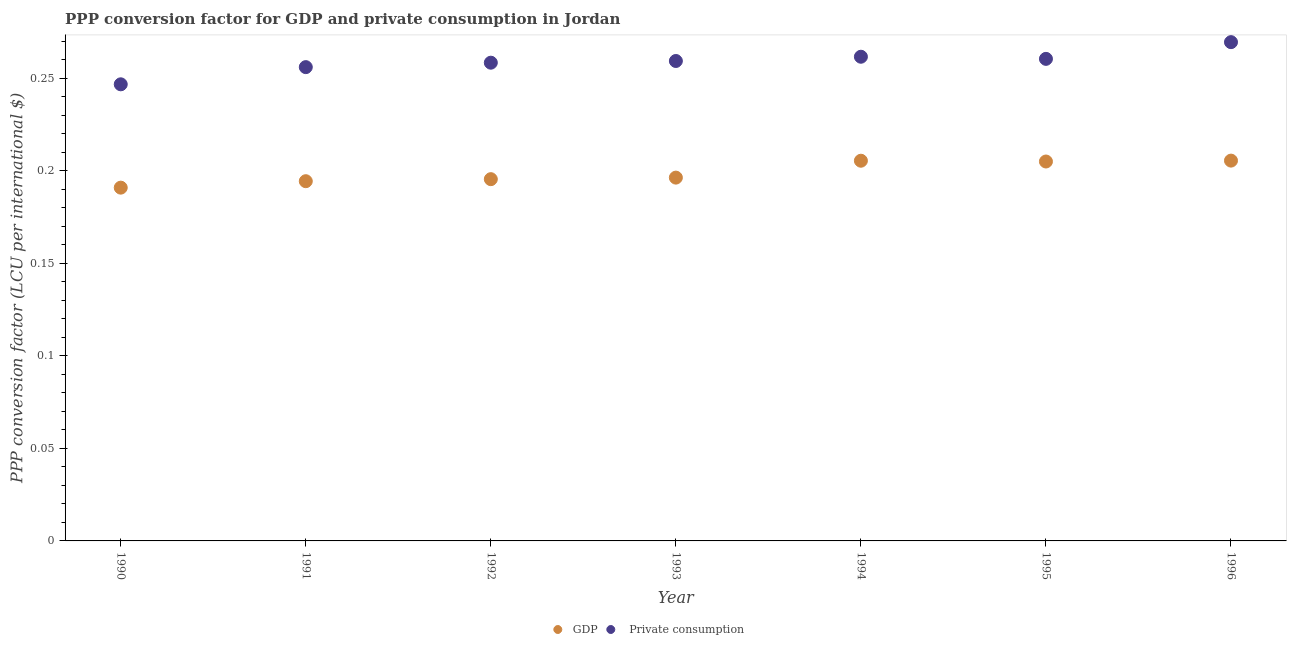How many different coloured dotlines are there?
Make the answer very short. 2. Is the number of dotlines equal to the number of legend labels?
Your response must be concise. Yes. What is the ppp conversion factor for gdp in 1992?
Provide a short and direct response. 0.2. Across all years, what is the maximum ppp conversion factor for private consumption?
Give a very brief answer. 0.27. Across all years, what is the minimum ppp conversion factor for gdp?
Make the answer very short. 0.19. In which year was the ppp conversion factor for private consumption maximum?
Give a very brief answer. 1996. In which year was the ppp conversion factor for gdp minimum?
Give a very brief answer. 1990. What is the total ppp conversion factor for gdp in the graph?
Your response must be concise. 1.39. What is the difference between the ppp conversion factor for private consumption in 1992 and that in 1995?
Make the answer very short. -0. What is the difference between the ppp conversion factor for gdp in 1993 and the ppp conversion factor for private consumption in 1996?
Make the answer very short. -0.07. What is the average ppp conversion factor for private consumption per year?
Your answer should be very brief. 0.26. In the year 1992, what is the difference between the ppp conversion factor for private consumption and ppp conversion factor for gdp?
Give a very brief answer. 0.06. What is the ratio of the ppp conversion factor for gdp in 1990 to that in 1992?
Ensure brevity in your answer.  0.98. Is the ppp conversion factor for private consumption in 1992 less than that in 1995?
Ensure brevity in your answer.  Yes. What is the difference between the highest and the second highest ppp conversion factor for gdp?
Provide a succinct answer. 6.120012639210248e-5. What is the difference between the highest and the lowest ppp conversion factor for gdp?
Your answer should be compact. 0.01. Is the sum of the ppp conversion factor for private consumption in 1994 and 1995 greater than the maximum ppp conversion factor for gdp across all years?
Your response must be concise. Yes. How many years are there in the graph?
Offer a terse response. 7. What is the difference between two consecutive major ticks on the Y-axis?
Offer a terse response. 0.05. Does the graph contain any zero values?
Your response must be concise. No. Where does the legend appear in the graph?
Keep it short and to the point. Bottom center. How many legend labels are there?
Give a very brief answer. 2. How are the legend labels stacked?
Make the answer very short. Horizontal. What is the title of the graph?
Offer a terse response. PPP conversion factor for GDP and private consumption in Jordan. Does "Borrowers" appear as one of the legend labels in the graph?
Give a very brief answer. No. What is the label or title of the X-axis?
Offer a very short reply. Year. What is the label or title of the Y-axis?
Provide a succinct answer. PPP conversion factor (LCU per international $). What is the PPP conversion factor (LCU per international $) in GDP in 1990?
Offer a terse response. 0.19. What is the PPP conversion factor (LCU per international $) in  Private consumption in 1990?
Your response must be concise. 0.25. What is the PPP conversion factor (LCU per international $) in GDP in 1991?
Offer a very short reply. 0.19. What is the PPP conversion factor (LCU per international $) in  Private consumption in 1991?
Make the answer very short. 0.26. What is the PPP conversion factor (LCU per international $) of GDP in 1992?
Your response must be concise. 0.2. What is the PPP conversion factor (LCU per international $) in  Private consumption in 1992?
Offer a very short reply. 0.26. What is the PPP conversion factor (LCU per international $) in GDP in 1993?
Provide a short and direct response. 0.2. What is the PPP conversion factor (LCU per international $) of  Private consumption in 1993?
Your answer should be very brief. 0.26. What is the PPP conversion factor (LCU per international $) in GDP in 1994?
Offer a terse response. 0.21. What is the PPP conversion factor (LCU per international $) of  Private consumption in 1994?
Give a very brief answer. 0.26. What is the PPP conversion factor (LCU per international $) in GDP in 1995?
Provide a succinct answer. 0.21. What is the PPP conversion factor (LCU per international $) in  Private consumption in 1995?
Your answer should be very brief. 0.26. What is the PPP conversion factor (LCU per international $) in GDP in 1996?
Provide a short and direct response. 0.21. What is the PPP conversion factor (LCU per international $) of  Private consumption in 1996?
Ensure brevity in your answer.  0.27. Across all years, what is the maximum PPP conversion factor (LCU per international $) of GDP?
Your answer should be very brief. 0.21. Across all years, what is the maximum PPP conversion factor (LCU per international $) in  Private consumption?
Offer a terse response. 0.27. Across all years, what is the minimum PPP conversion factor (LCU per international $) of GDP?
Offer a terse response. 0.19. Across all years, what is the minimum PPP conversion factor (LCU per international $) in  Private consumption?
Ensure brevity in your answer.  0.25. What is the total PPP conversion factor (LCU per international $) of GDP in the graph?
Provide a short and direct response. 1.39. What is the total PPP conversion factor (LCU per international $) of  Private consumption in the graph?
Provide a short and direct response. 1.81. What is the difference between the PPP conversion factor (LCU per international $) of GDP in 1990 and that in 1991?
Your response must be concise. -0. What is the difference between the PPP conversion factor (LCU per international $) of  Private consumption in 1990 and that in 1991?
Give a very brief answer. -0.01. What is the difference between the PPP conversion factor (LCU per international $) of GDP in 1990 and that in 1992?
Make the answer very short. -0. What is the difference between the PPP conversion factor (LCU per international $) in  Private consumption in 1990 and that in 1992?
Your answer should be compact. -0.01. What is the difference between the PPP conversion factor (LCU per international $) in GDP in 1990 and that in 1993?
Your answer should be very brief. -0.01. What is the difference between the PPP conversion factor (LCU per international $) of  Private consumption in 1990 and that in 1993?
Give a very brief answer. -0.01. What is the difference between the PPP conversion factor (LCU per international $) in GDP in 1990 and that in 1994?
Your response must be concise. -0.01. What is the difference between the PPP conversion factor (LCU per international $) of  Private consumption in 1990 and that in 1994?
Keep it short and to the point. -0.01. What is the difference between the PPP conversion factor (LCU per international $) in GDP in 1990 and that in 1995?
Offer a terse response. -0.01. What is the difference between the PPP conversion factor (LCU per international $) in  Private consumption in 1990 and that in 1995?
Provide a short and direct response. -0.01. What is the difference between the PPP conversion factor (LCU per international $) of GDP in 1990 and that in 1996?
Give a very brief answer. -0.01. What is the difference between the PPP conversion factor (LCU per international $) in  Private consumption in 1990 and that in 1996?
Your answer should be very brief. -0.02. What is the difference between the PPP conversion factor (LCU per international $) of GDP in 1991 and that in 1992?
Offer a very short reply. -0. What is the difference between the PPP conversion factor (LCU per international $) in  Private consumption in 1991 and that in 1992?
Keep it short and to the point. -0. What is the difference between the PPP conversion factor (LCU per international $) in GDP in 1991 and that in 1993?
Your answer should be compact. -0. What is the difference between the PPP conversion factor (LCU per international $) of  Private consumption in 1991 and that in 1993?
Offer a very short reply. -0. What is the difference between the PPP conversion factor (LCU per international $) in GDP in 1991 and that in 1994?
Keep it short and to the point. -0.01. What is the difference between the PPP conversion factor (LCU per international $) of  Private consumption in 1991 and that in 1994?
Your answer should be compact. -0.01. What is the difference between the PPP conversion factor (LCU per international $) of GDP in 1991 and that in 1995?
Your response must be concise. -0.01. What is the difference between the PPP conversion factor (LCU per international $) in  Private consumption in 1991 and that in 1995?
Provide a succinct answer. -0. What is the difference between the PPP conversion factor (LCU per international $) of GDP in 1991 and that in 1996?
Give a very brief answer. -0.01. What is the difference between the PPP conversion factor (LCU per international $) in  Private consumption in 1991 and that in 1996?
Offer a very short reply. -0.01. What is the difference between the PPP conversion factor (LCU per international $) in GDP in 1992 and that in 1993?
Give a very brief answer. -0. What is the difference between the PPP conversion factor (LCU per international $) of  Private consumption in 1992 and that in 1993?
Provide a succinct answer. -0. What is the difference between the PPP conversion factor (LCU per international $) of GDP in 1992 and that in 1994?
Keep it short and to the point. -0.01. What is the difference between the PPP conversion factor (LCU per international $) in  Private consumption in 1992 and that in 1994?
Provide a short and direct response. -0. What is the difference between the PPP conversion factor (LCU per international $) of GDP in 1992 and that in 1995?
Your answer should be compact. -0.01. What is the difference between the PPP conversion factor (LCU per international $) in  Private consumption in 1992 and that in 1995?
Your answer should be compact. -0. What is the difference between the PPP conversion factor (LCU per international $) in GDP in 1992 and that in 1996?
Offer a very short reply. -0.01. What is the difference between the PPP conversion factor (LCU per international $) of  Private consumption in 1992 and that in 1996?
Provide a succinct answer. -0.01. What is the difference between the PPP conversion factor (LCU per international $) of GDP in 1993 and that in 1994?
Ensure brevity in your answer.  -0.01. What is the difference between the PPP conversion factor (LCU per international $) in  Private consumption in 1993 and that in 1994?
Offer a very short reply. -0. What is the difference between the PPP conversion factor (LCU per international $) of GDP in 1993 and that in 1995?
Make the answer very short. -0.01. What is the difference between the PPP conversion factor (LCU per international $) of  Private consumption in 1993 and that in 1995?
Offer a very short reply. -0. What is the difference between the PPP conversion factor (LCU per international $) of GDP in 1993 and that in 1996?
Your response must be concise. -0.01. What is the difference between the PPP conversion factor (LCU per international $) of  Private consumption in 1993 and that in 1996?
Offer a very short reply. -0.01. What is the difference between the PPP conversion factor (LCU per international $) in GDP in 1994 and that in 1995?
Make the answer very short. 0. What is the difference between the PPP conversion factor (LCU per international $) in  Private consumption in 1994 and that in 1995?
Provide a short and direct response. 0. What is the difference between the PPP conversion factor (LCU per international $) of GDP in 1994 and that in 1996?
Your answer should be compact. -0. What is the difference between the PPP conversion factor (LCU per international $) of  Private consumption in 1994 and that in 1996?
Give a very brief answer. -0.01. What is the difference between the PPP conversion factor (LCU per international $) of GDP in 1995 and that in 1996?
Provide a succinct answer. -0. What is the difference between the PPP conversion factor (LCU per international $) of  Private consumption in 1995 and that in 1996?
Keep it short and to the point. -0.01. What is the difference between the PPP conversion factor (LCU per international $) in GDP in 1990 and the PPP conversion factor (LCU per international $) in  Private consumption in 1991?
Offer a terse response. -0.07. What is the difference between the PPP conversion factor (LCU per international $) of GDP in 1990 and the PPP conversion factor (LCU per international $) of  Private consumption in 1992?
Your answer should be very brief. -0.07. What is the difference between the PPP conversion factor (LCU per international $) in GDP in 1990 and the PPP conversion factor (LCU per international $) in  Private consumption in 1993?
Provide a short and direct response. -0.07. What is the difference between the PPP conversion factor (LCU per international $) of GDP in 1990 and the PPP conversion factor (LCU per international $) of  Private consumption in 1994?
Offer a terse response. -0.07. What is the difference between the PPP conversion factor (LCU per international $) in GDP in 1990 and the PPP conversion factor (LCU per international $) in  Private consumption in 1995?
Ensure brevity in your answer.  -0.07. What is the difference between the PPP conversion factor (LCU per international $) of GDP in 1990 and the PPP conversion factor (LCU per international $) of  Private consumption in 1996?
Offer a very short reply. -0.08. What is the difference between the PPP conversion factor (LCU per international $) of GDP in 1991 and the PPP conversion factor (LCU per international $) of  Private consumption in 1992?
Provide a succinct answer. -0.06. What is the difference between the PPP conversion factor (LCU per international $) of GDP in 1991 and the PPP conversion factor (LCU per international $) of  Private consumption in 1993?
Your answer should be very brief. -0.07. What is the difference between the PPP conversion factor (LCU per international $) of GDP in 1991 and the PPP conversion factor (LCU per international $) of  Private consumption in 1994?
Your answer should be very brief. -0.07. What is the difference between the PPP conversion factor (LCU per international $) in GDP in 1991 and the PPP conversion factor (LCU per international $) in  Private consumption in 1995?
Your answer should be compact. -0.07. What is the difference between the PPP conversion factor (LCU per international $) of GDP in 1991 and the PPP conversion factor (LCU per international $) of  Private consumption in 1996?
Provide a succinct answer. -0.08. What is the difference between the PPP conversion factor (LCU per international $) in GDP in 1992 and the PPP conversion factor (LCU per international $) in  Private consumption in 1993?
Give a very brief answer. -0.06. What is the difference between the PPP conversion factor (LCU per international $) of GDP in 1992 and the PPP conversion factor (LCU per international $) of  Private consumption in 1994?
Your answer should be very brief. -0.07. What is the difference between the PPP conversion factor (LCU per international $) in GDP in 1992 and the PPP conversion factor (LCU per international $) in  Private consumption in 1995?
Provide a succinct answer. -0.07. What is the difference between the PPP conversion factor (LCU per international $) in GDP in 1992 and the PPP conversion factor (LCU per international $) in  Private consumption in 1996?
Give a very brief answer. -0.07. What is the difference between the PPP conversion factor (LCU per international $) of GDP in 1993 and the PPP conversion factor (LCU per international $) of  Private consumption in 1994?
Your answer should be compact. -0.07. What is the difference between the PPP conversion factor (LCU per international $) in GDP in 1993 and the PPP conversion factor (LCU per international $) in  Private consumption in 1995?
Offer a terse response. -0.06. What is the difference between the PPP conversion factor (LCU per international $) in GDP in 1993 and the PPP conversion factor (LCU per international $) in  Private consumption in 1996?
Offer a terse response. -0.07. What is the difference between the PPP conversion factor (LCU per international $) in GDP in 1994 and the PPP conversion factor (LCU per international $) in  Private consumption in 1995?
Offer a very short reply. -0.06. What is the difference between the PPP conversion factor (LCU per international $) of GDP in 1994 and the PPP conversion factor (LCU per international $) of  Private consumption in 1996?
Keep it short and to the point. -0.06. What is the difference between the PPP conversion factor (LCU per international $) of GDP in 1995 and the PPP conversion factor (LCU per international $) of  Private consumption in 1996?
Your answer should be very brief. -0.06. What is the average PPP conversion factor (LCU per international $) of GDP per year?
Provide a short and direct response. 0.2. What is the average PPP conversion factor (LCU per international $) of  Private consumption per year?
Provide a short and direct response. 0.26. In the year 1990, what is the difference between the PPP conversion factor (LCU per international $) of GDP and PPP conversion factor (LCU per international $) of  Private consumption?
Offer a terse response. -0.06. In the year 1991, what is the difference between the PPP conversion factor (LCU per international $) in GDP and PPP conversion factor (LCU per international $) in  Private consumption?
Ensure brevity in your answer.  -0.06. In the year 1992, what is the difference between the PPP conversion factor (LCU per international $) of GDP and PPP conversion factor (LCU per international $) of  Private consumption?
Keep it short and to the point. -0.06. In the year 1993, what is the difference between the PPP conversion factor (LCU per international $) in GDP and PPP conversion factor (LCU per international $) in  Private consumption?
Your response must be concise. -0.06. In the year 1994, what is the difference between the PPP conversion factor (LCU per international $) in GDP and PPP conversion factor (LCU per international $) in  Private consumption?
Your response must be concise. -0.06. In the year 1995, what is the difference between the PPP conversion factor (LCU per international $) in GDP and PPP conversion factor (LCU per international $) in  Private consumption?
Your answer should be very brief. -0.06. In the year 1996, what is the difference between the PPP conversion factor (LCU per international $) in GDP and PPP conversion factor (LCU per international $) in  Private consumption?
Your answer should be very brief. -0.06. What is the ratio of the PPP conversion factor (LCU per international $) of GDP in 1990 to that in 1991?
Make the answer very short. 0.98. What is the ratio of the PPP conversion factor (LCU per international $) in  Private consumption in 1990 to that in 1991?
Give a very brief answer. 0.96. What is the ratio of the PPP conversion factor (LCU per international $) of GDP in 1990 to that in 1992?
Your answer should be very brief. 0.98. What is the ratio of the PPP conversion factor (LCU per international $) of  Private consumption in 1990 to that in 1992?
Give a very brief answer. 0.95. What is the ratio of the PPP conversion factor (LCU per international $) in GDP in 1990 to that in 1993?
Give a very brief answer. 0.97. What is the ratio of the PPP conversion factor (LCU per international $) in  Private consumption in 1990 to that in 1993?
Provide a short and direct response. 0.95. What is the ratio of the PPP conversion factor (LCU per international $) of GDP in 1990 to that in 1994?
Ensure brevity in your answer.  0.93. What is the ratio of the PPP conversion factor (LCU per international $) of  Private consumption in 1990 to that in 1994?
Provide a short and direct response. 0.94. What is the ratio of the PPP conversion factor (LCU per international $) of GDP in 1990 to that in 1995?
Keep it short and to the point. 0.93. What is the ratio of the PPP conversion factor (LCU per international $) in  Private consumption in 1990 to that in 1995?
Provide a short and direct response. 0.95. What is the ratio of the PPP conversion factor (LCU per international $) of GDP in 1990 to that in 1996?
Ensure brevity in your answer.  0.93. What is the ratio of the PPP conversion factor (LCU per international $) of  Private consumption in 1990 to that in 1996?
Give a very brief answer. 0.92. What is the ratio of the PPP conversion factor (LCU per international $) of GDP in 1991 to that in 1992?
Give a very brief answer. 0.99. What is the ratio of the PPP conversion factor (LCU per international $) of GDP in 1991 to that in 1993?
Keep it short and to the point. 0.99. What is the ratio of the PPP conversion factor (LCU per international $) of  Private consumption in 1991 to that in 1993?
Make the answer very short. 0.99. What is the ratio of the PPP conversion factor (LCU per international $) in GDP in 1991 to that in 1994?
Make the answer very short. 0.95. What is the ratio of the PPP conversion factor (LCU per international $) in  Private consumption in 1991 to that in 1994?
Your response must be concise. 0.98. What is the ratio of the PPP conversion factor (LCU per international $) of GDP in 1991 to that in 1995?
Your answer should be compact. 0.95. What is the ratio of the PPP conversion factor (LCU per international $) in  Private consumption in 1991 to that in 1995?
Ensure brevity in your answer.  0.98. What is the ratio of the PPP conversion factor (LCU per international $) of GDP in 1991 to that in 1996?
Ensure brevity in your answer.  0.95. What is the ratio of the PPP conversion factor (LCU per international $) of  Private consumption in 1991 to that in 1996?
Offer a very short reply. 0.95. What is the ratio of the PPP conversion factor (LCU per international $) in GDP in 1992 to that in 1993?
Your answer should be compact. 1. What is the ratio of the PPP conversion factor (LCU per international $) in  Private consumption in 1992 to that in 1993?
Offer a very short reply. 1. What is the ratio of the PPP conversion factor (LCU per international $) of GDP in 1992 to that in 1994?
Provide a succinct answer. 0.95. What is the ratio of the PPP conversion factor (LCU per international $) in GDP in 1992 to that in 1995?
Your response must be concise. 0.95. What is the ratio of the PPP conversion factor (LCU per international $) in GDP in 1992 to that in 1996?
Your answer should be compact. 0.95. What is the ratio of the PPP conversion factor (LCU per international $) in  Private consumption in 1992 to that in 1996?
Keep it short and to the point. 0.96. What is the ratio of the PPP conversion factor (LCU per international $) of GDP in 1993 to that in 1994?
Your response must be concise. 0.96. What is the ratio of the PPP conversion factor (LCU per international $) in GDP in 1993 to that in 1995?
Offer a very short reply. 0.96. What is the ratio of the PPP conversion factor (LCU per international $) of  Private consumption in 1993 to that in 1995?
Your answer should be compact. 1. What is the ratio of the PPP conversion factor (LCU per international $) of GDP in 1993 to that in 1996?
Ensure brevity in your answer.  0.96. What is the ratio of the PPP conversion factor (LCU per international $) of  Private consumption in 1993 to that in 1996?
Your response must be concise. 0.96. What is the ratio of the PPP conversion factor (LCU per international $) in  Private consumption in 1994 to that in 1996?
Keep it short and to the point. 0.97. What is the ratio of the PPP conversion factor (LCU per international $) in  Private consumption in 1995 to that in 1996?
Give a very brief answer. 0.97. What is the difference between the highest and the second highest PPP conversion factor (LCU per international $) of GDP?
Give a very brief answer. 0. What is the difference between the highest and the second highest PPP conversion factor (LCU per international $) of  Private consumption?
Give a very brief answer. 0.01. What is the difference between the highest and the lowest PPP conversion factor (LCU per international $) of GDP?
Provide a short and direct response. 0.01. What is the difference between the highest and the lowest PPP conversion factor (LCU per international $) in  Private consumption?
Keep it short and to the point. 0.02. 